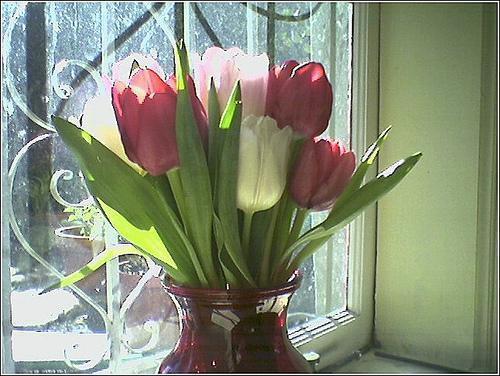How many potted plants are there?
Give a very brief answer. 2. 